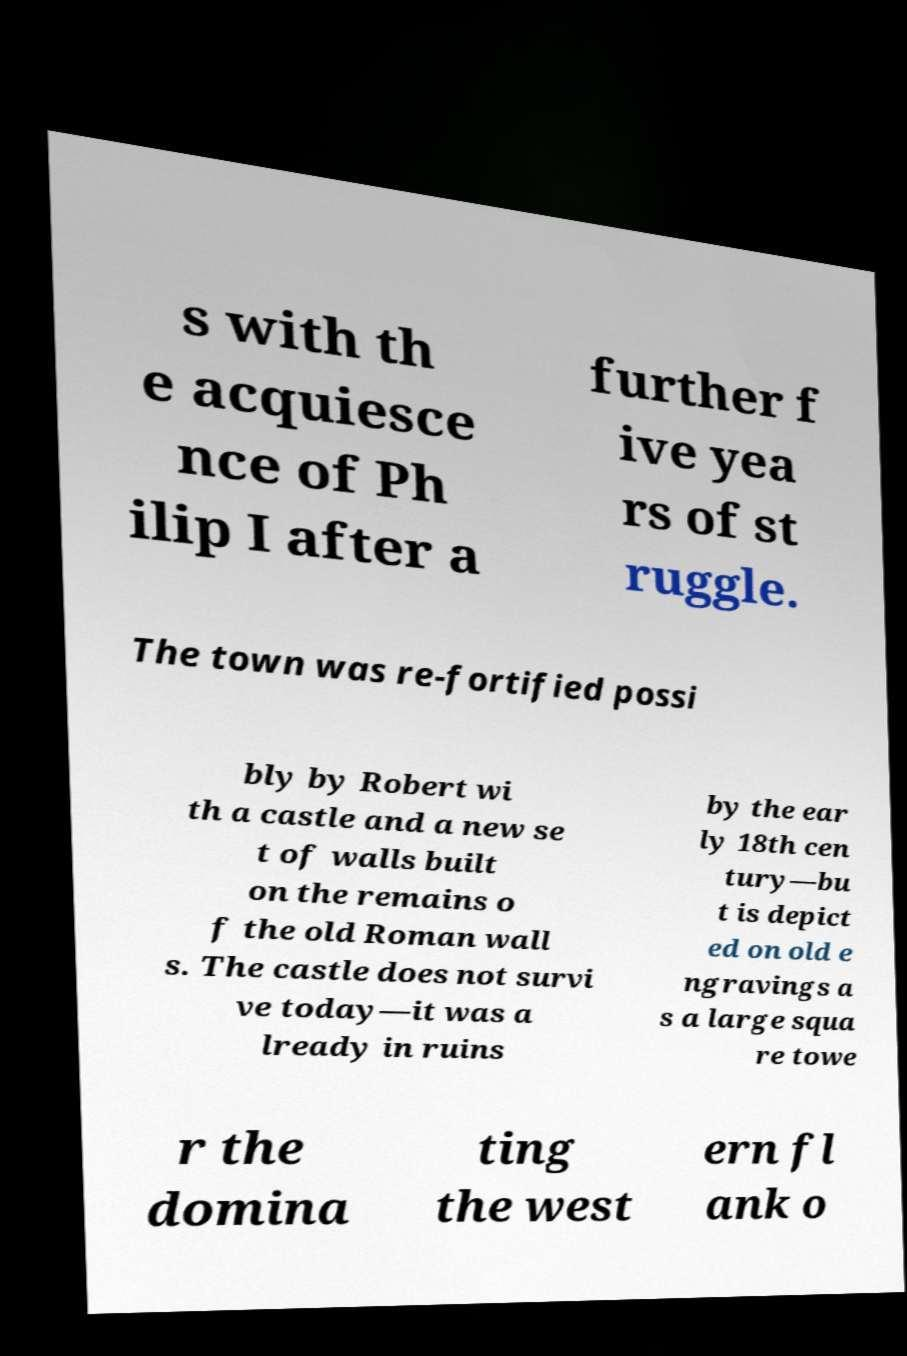I need the written content from this picture converted into text. Can you do that? s with th e acquiesce nce of Ph ilip I after a further f ive yea rs of st ruggle. The town was re-fortified possi bly by Robert wi th a castle and a new se t of walls built on the remains o f the old Roman wall s. The castle does not survi ve today—it was a lready in ruins by the ear ly 18th cen tury—bu t is depict ed on old e ngravings a s a large squa re towe r the domina ting the west ern fl ank o 